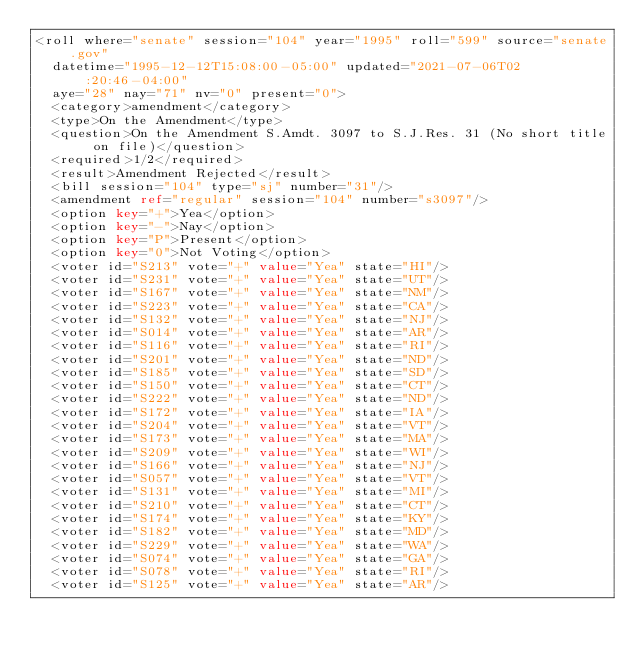<code> <loc_0><loc_0><loc_500><loc_500><_XML_><roll where="senate" session="104" year="1995" roll="599" source="senate.gov"
  datetime="1995-12-12T15:08:00-05:00" updated="2021-07-06T02:20:46-04:00"
  aye="28" nay="71" nv="0" present="0">
  <category>amendment</category>
  <type>On the Amendment</type>
  <question>On the Amendment S.Amdt. 3097 to S.J.Res. 31 (No short title on file)</question>
  <required>1/2</required>
  <result>Amendment Rejected</result>
  <bill session="104" type="sj" number="31"/>
  <amendment ref="regular" session="104" number="s3097"/>
  <option key="+">Yea</option>
  <option key="-">Nay</option>
  <option key="P">Present</option>
  <option key="0">Not Voting</option>
  <voter id="S213" vote="+" value="Yea" state="HI"/>
  <voter id="S231" vote="+" value="Yea" state="UT"/>
  <voter id="S167" vote="+" value="Yea" state="NM"/>
  <voter id="S223" vote="+" value="Yea" state="CA"/>
  <voter id="S132" vote="+" value="Yea" state="NJ"/>
  <voter id="S014" vote="+" value="Yea" state="AR"/>
  <voter id="S116" vote="+" value="Yea" state="RI"/>
  <voter id="S201" vote="+" value="Yea" state="ND"/>
  <voter id="S185" vote="+" value="Yea" state="SD"/>
  <voter id="S150" vote="+" value="Yea" state="CT"/>
  <voter id="S222" vote="+" value="Yea" state="ND"/>
  <voter id="S172" vote="+" value="Yea" state="IA"/>
  <voter id="S204" vote="+" value="Yea" state="VT"/>
  <voter id="S173" vote="+" value="Yea" state="MA"/>
  <voter id="S209" vote="+" value="Yea" state="WI"/>
  <voter id="S166" vote="+" value="Yea" state="NJ"/>
  <voter id="S057" vote="+" value="Yea" state="VT"/>
  <voter id="S131" vote="+" value="Yea" state="MI"/>
  <voter id="S210" vote="+" value="Yea" state="CT"/>
  <voter id="S174" vote="+" value="Yea" state="KY"/>
  <voter id="S182" vote="+" value="Yea" state="MD"/>
  <voter id="S229" vote="+" value="Yea" state="WA"/>
  <voter id="S074" vote="+" value="Yea" state="GA"/>
  <voter id="S078" vote="+" value="Yea" state="RI"/>
  <voter id="S125" vote="+" value="Yea" state="AR"/></code> 